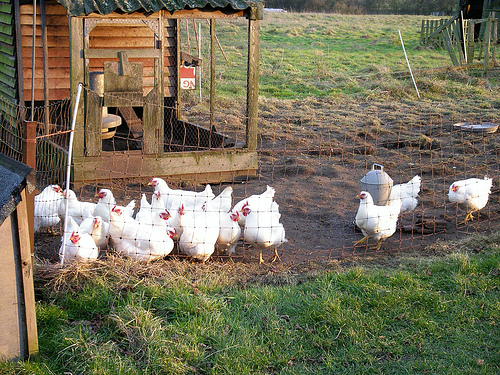<image>
Is the chicken on the grass? No. The chicken is not positioned on the grass. They may be near each other, but the chicken is not supported by or resting on top of the grass. Is the chicken behind the fence? Yes. From this viewpoint, the chicken is positioned behind the fence, with the fence partially or fully occluding the chicken. Where is the hen in relation to the grass? Is it behind the grass? Yes. From this viewpoint, the hen is positioned behind the grass, with the grass partially or fully occluding the hen. Is there a chicken in front of the milk can? Yes. The chicken is positioned in front of the milk can, appearing closer to the camera viewpoint. 